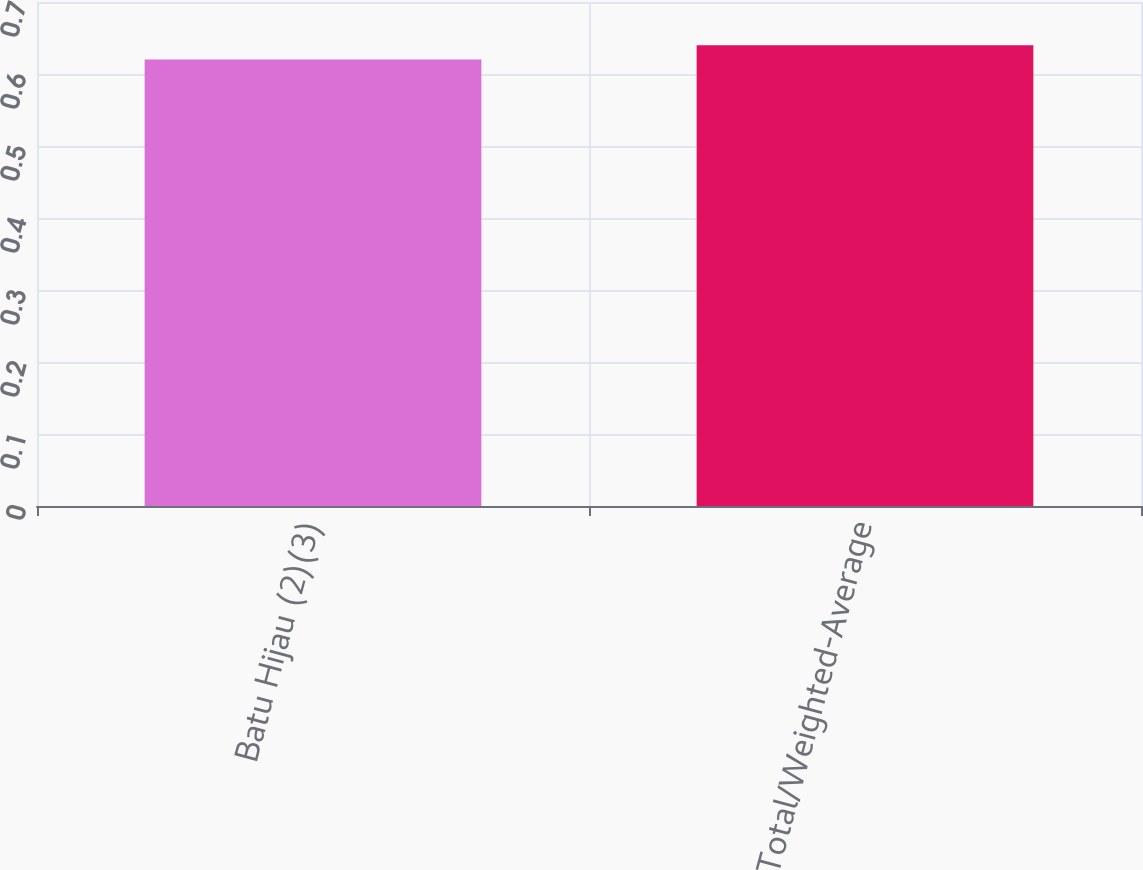<chart> <loc_0><loc_0><loc_500><loc_500><bar_chart><fcel>Batu Hijau (2)(3)<fcel>Total/Weighted-Average<nl><fcel>0.62<fcel>0.64<nl></chart> 